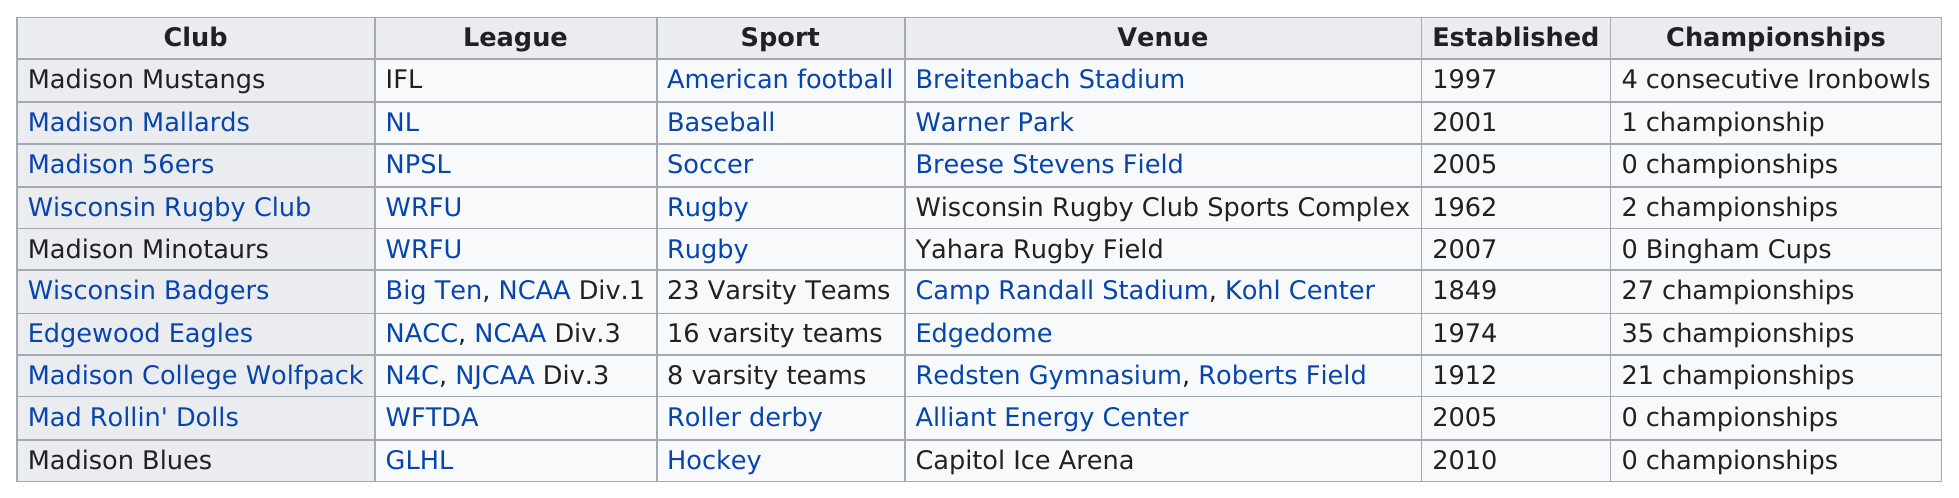Draw attention to some important aspects in this diagram. There are currently 4 teams that have been in existence for 25 years or more. The Madison College Wolfpack has been established for 102 years. With a total of 20 championships, the Edgewood Eagles have established themselves as the top team in the league. Out of the Madison sports teams that have won at least two championships, five have accomplished this feat. The Wisconsin Badgers were established before any of the Madison sports teams. 